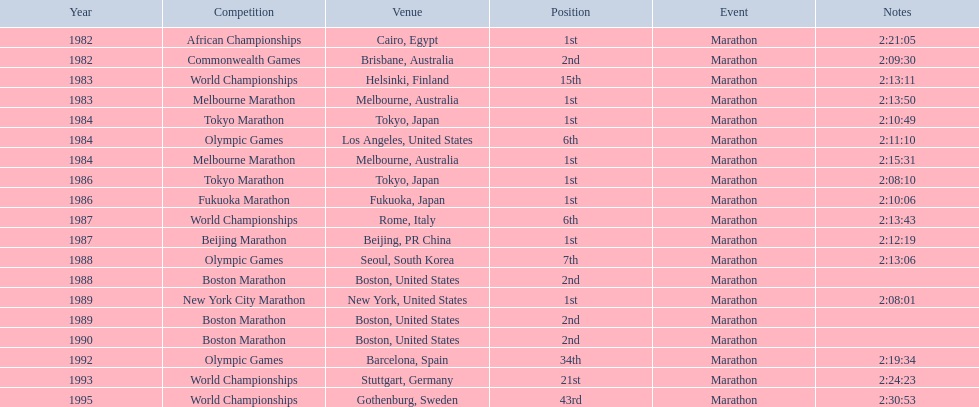In which year did the athlete take part in the highest number of marathons? 1984. 